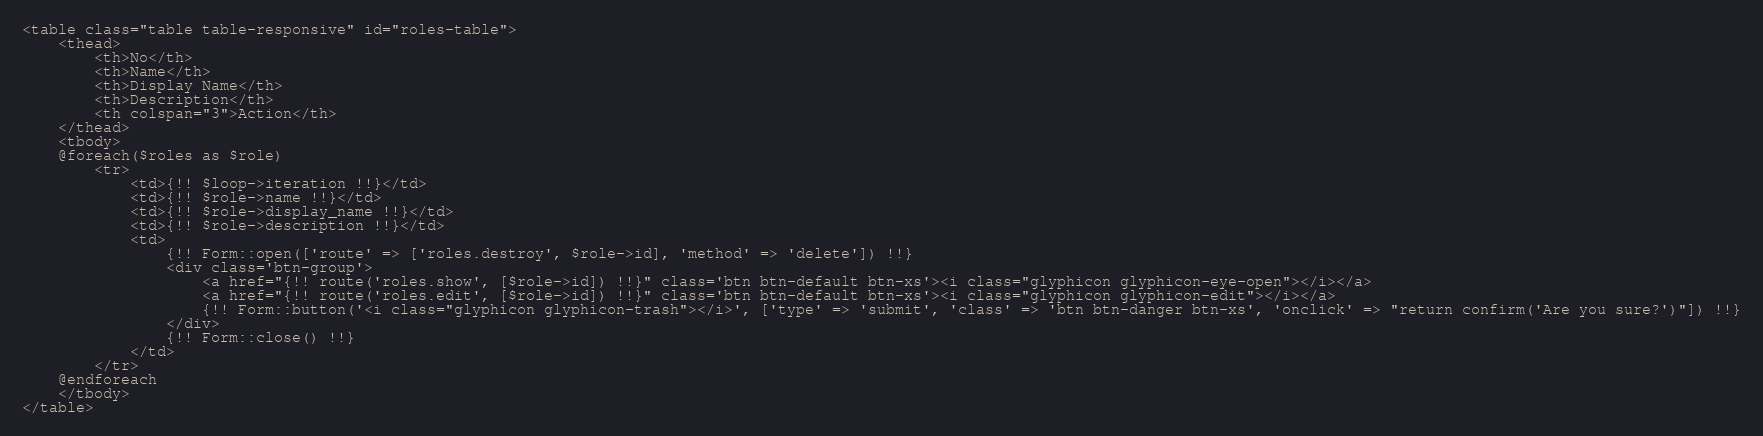<code> <loc_0><loc_0><loc_500><loc_500><_PHP_><table class="table table-responsive" id="roles-table">
    <thead>
        <th>No</th>
        <th>Name</th>
        <th>Display Name</th>
        <th>Description</th>
        <th colspan="3">Action</th>
    </thead>
    <tbody>
    @foreach($roles as $role)
        <tr>
            <td>{!! $loop->iteration !!}</td>
            <td>{!! $role->name !!}</td>
            <td>{!! $role->display_name !!}</td>
            <td>{!! $role->description !!}</td>
            <td>
                {!! Form::open(['route' => ['roles.destroy', $role->id], 'method' => 'delete']) !!}
                <div class='btn-group'>
                    <a href="{!! route('roles.show', [$role->id]) !!}" class='btn btn-default btn-xs'><i class="glyphicon glyphicon-eye-open"></i></a>
                    <a href="{!! route('roles.edit', [$role->id]) !!}" class='btn btn-default btn-xs'><i class="glyphicon glyphicon-edit"></i></a>
                    {!! Form::button('<i class="glyphicon glyphicon-trash"></i>', ['type' => 'submit', 'class' => 'btn btn-danger btn-xs', 'onclick' => "return confirm('Are you sure?')"]) !!}
                </div>
                {!! Form::close() !!}
            </td>
        </tr>
    @endforeach
    </tbody>
</table></code> 